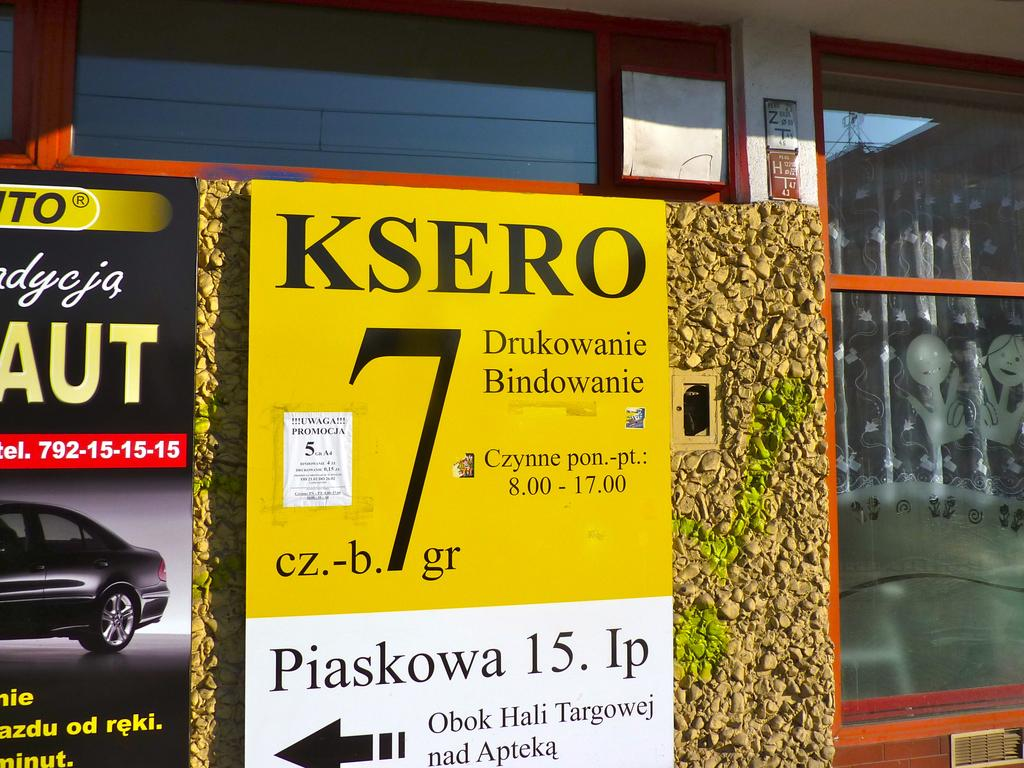What is the main subject in the center of the image? There is a building in the center of the image. What else can be seen in the image besides the building? Boards are visible in the image. What type of coil is being used to treat the disease in the image? There is no coil or disease present in the image; it only features a building and boards. 